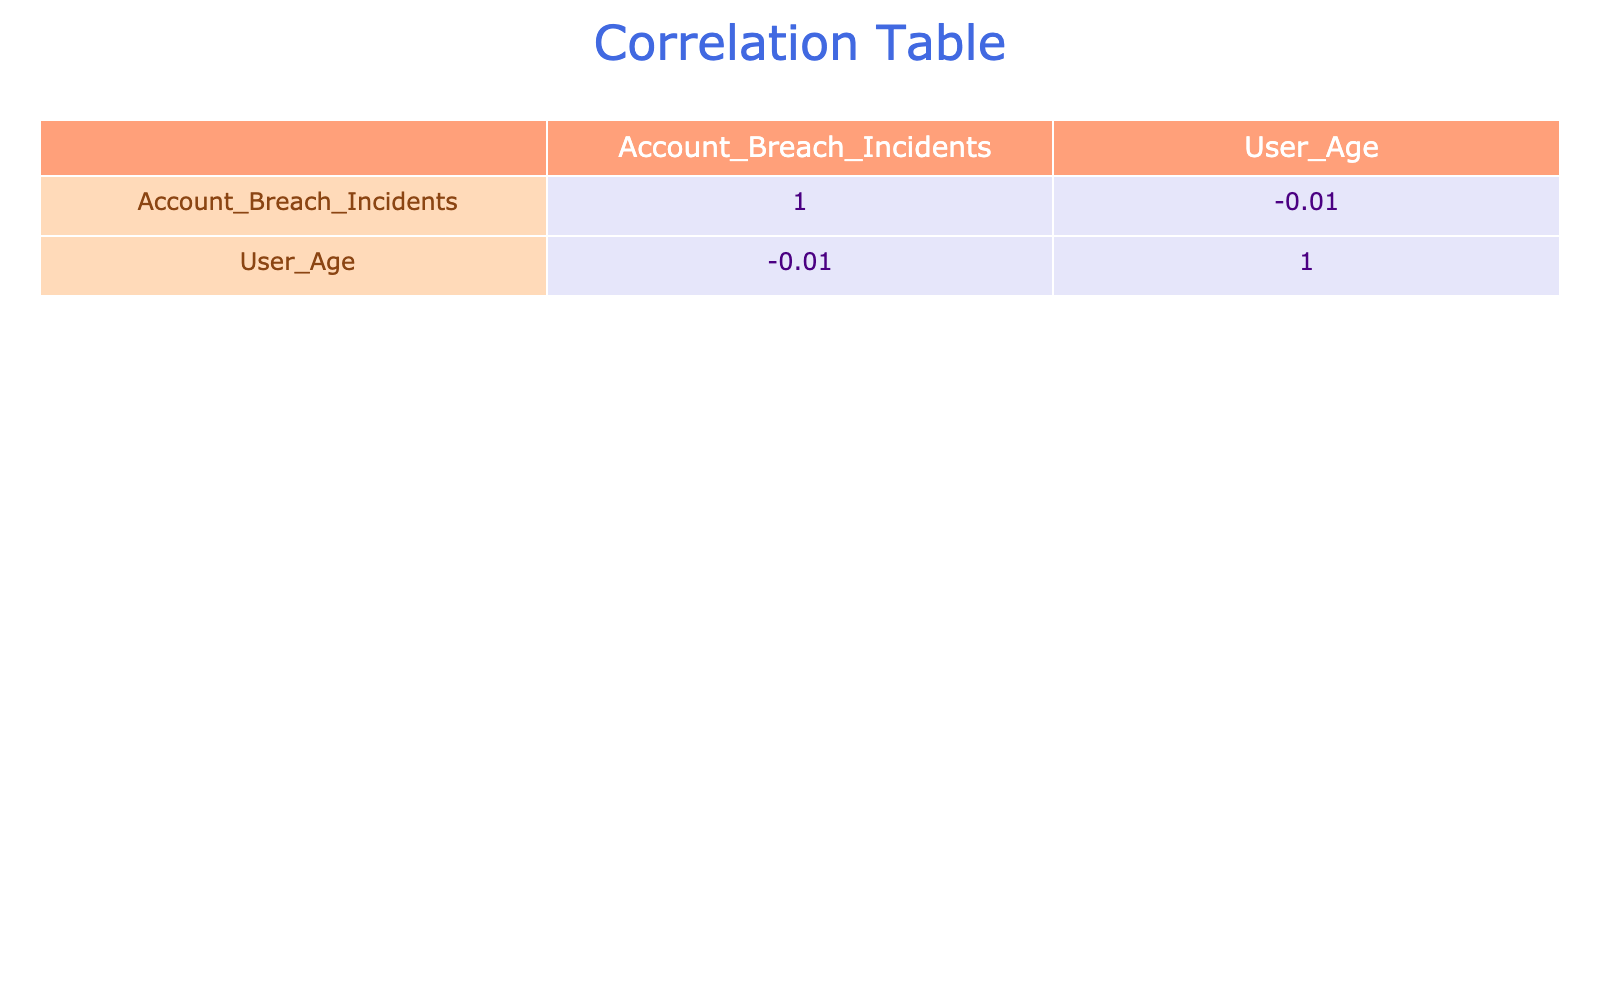What is the correlation between Password Strength and Account Breach Incidents? The table shows that as Password Strength improves from Weak to Strong, the number of Account Breach Incidents decreases. Weak passwords correlate with the highest number of incidents (30 and 40), while Strong passwords correlate with the least (5 and 2). This suggests a negative correlation.
Answer: Negative correlation What age group has the weakest passwords according to the table? By examining the Weak password entries, the ages associated are 65, 70, 60, and 80. The average of these ages is (65 + 70 + 60 + 80) / 4 = 68.75, so the age group around 68 years old has the weakest passwords.
Answer: Approximately 68 years old Do all Strong passwords lead to fewer breaches than Moderate passwords? Yes, when comparing Strong passwords (5 and 2 breaches totaling 7) to Moderate passwords (15 and 12 breaches totaling 27), Strong passwords consistently lead to fewer incidents than Moderate passwords.
Answer: Yes Which type of system has the highest reported Account Breach Incidents? Across the different systems, the data shows that the Government system has the highest reported incidents with 40 breaches. This is greater than any reported incidents for Social Media, Email, Banking, Healthcare, or News.
Answer: Government What is the difference in Account Breach Incidents between Weak and Strong passwords? The total for Weak passwords is (25 + 30 + 40 + 35) = 130, while for Strong passwords, it’s (5 + 3 + 2) = 10. The difference is 130 - 10 = 120, indicating a significant gap in incidents based on password strength.
Answer: 120 Is it true that the average age of users with Weak passwords is older than those with Strong passwords? Weak passwords are associated with ages 65, 70, 60, and 80 (average age = 68.75), while Strong passwords correspond to 72, 67, and 66 (average age = 68.33). Since 68.75 > 68.33, it is true.
Answer: Yes What is the total number of Account Breach Incidents for Moderate passwords? Adding the incidents: 15 (Banking) + 10 (Healthcare) + 12 (Email) = 37. This indicates that Moderate passwords have a collective total of 37 breaches.
Answer: 37 If we consider the average Account Breach Incidents across all password strengths, what do we get? The total breaches are 25 (Weak) + 30 + 15 (Moderate) + 10 + 5 (Strong) + 3 + 40 (Weak) + 12 + 2 (Strong) + 35 = 172. There are 10 entries, so the average is 172 / 10 = 17.2.
Answer: 17.2 Do users over the age of 70 mostly have Weak passwords? Looking at the ages above 70, we have 70 (Weak), 75 (Moderate), 72 (Strong), and 80 (Weak). There are two instances of Weak passwords (70 and 80) compared to one instance of a Strong password and one Moderate, which shows that the majority (2 out of 4) of users over 70 have Weak passwords.
Answer: Yes 